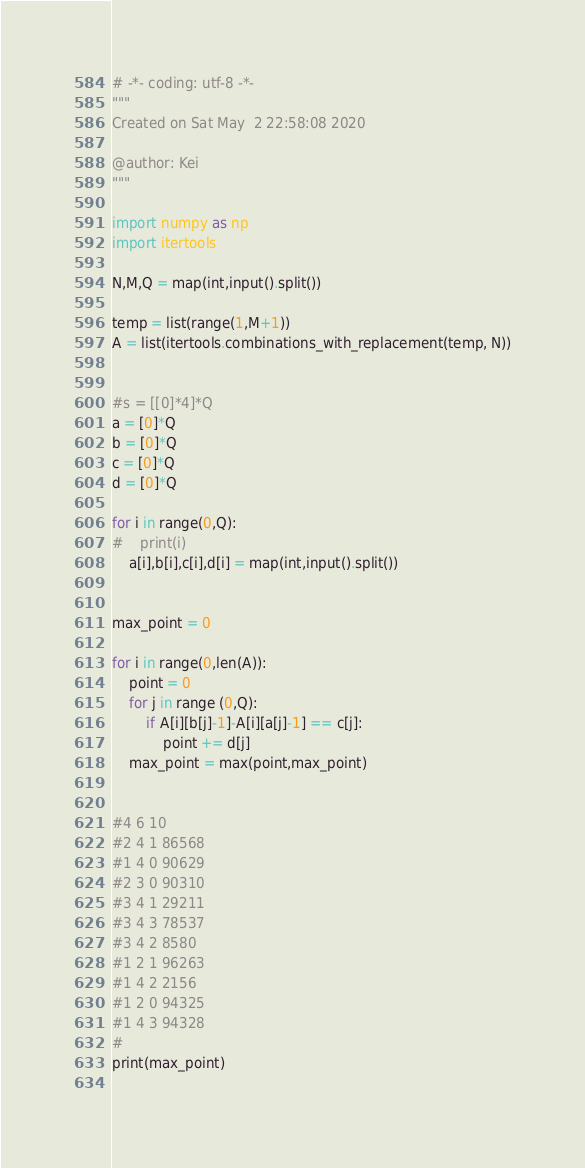Convert code to text. <code><loc_0><loc_0><loc_500><loc_500><_Python_># -*- coding: utf-8 -*-
"""
Created on Sat May  2 22:58:08 2020

@author: Kei
"""

import numpy as np
import itertools

N,M,Q = map(int,input().split())

temp = list(range(1,M+1))
A = list(itertools.combinations_with_replacement(temp, N))


#s = [[0]*4]*Q
a = [0]*Q
b = [0]*Q
c = [0]*Q
d = [0]*Q

for i in range(0,Q):
#    print(i)
    a[i],b[i],c[i],d[i] = map(int,input().split())
    

max_point = 0
    
for i in range(0,len(A)):
    point = 0
    for j in range (0,Q):
        if A[i][b[j]-1]-A[i][a[j]-1] == c[j]:
            point += d[j]
    max_point = max(point,max_point)
    

#4 6 10
#2 4 1 86568
#1 4 0 90629
#2 3 0 90310
#3 4 1 29211
#3 4 3 78537
#3 4 2 8580
#1 2 1 96263
#1 4 2 2156
#1 2 0 94325
#1 4 3 94328
#        
print(max_point)
        </code> 